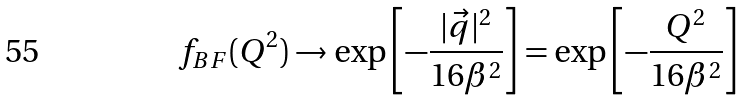Convert formula to latex. <formula><loc_0><loc_0><loc_500><loc_500>f _ { B F } ( Q ^ { 2 } ) \to \exp \left [ - \frac { | \vec { q } | ^ { 2 } } { 1 6 \beta ^ { 2 } } \right ] = \exp \left [ - \frac { Q ^ { 2 } } { 1 6 \beta ^ { 2 } } \right ]</formula> 